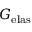Convert formula to latex. <formula><loc_0><loc_0><loc_500><loc_500>G _ { e l a s }</formula> 